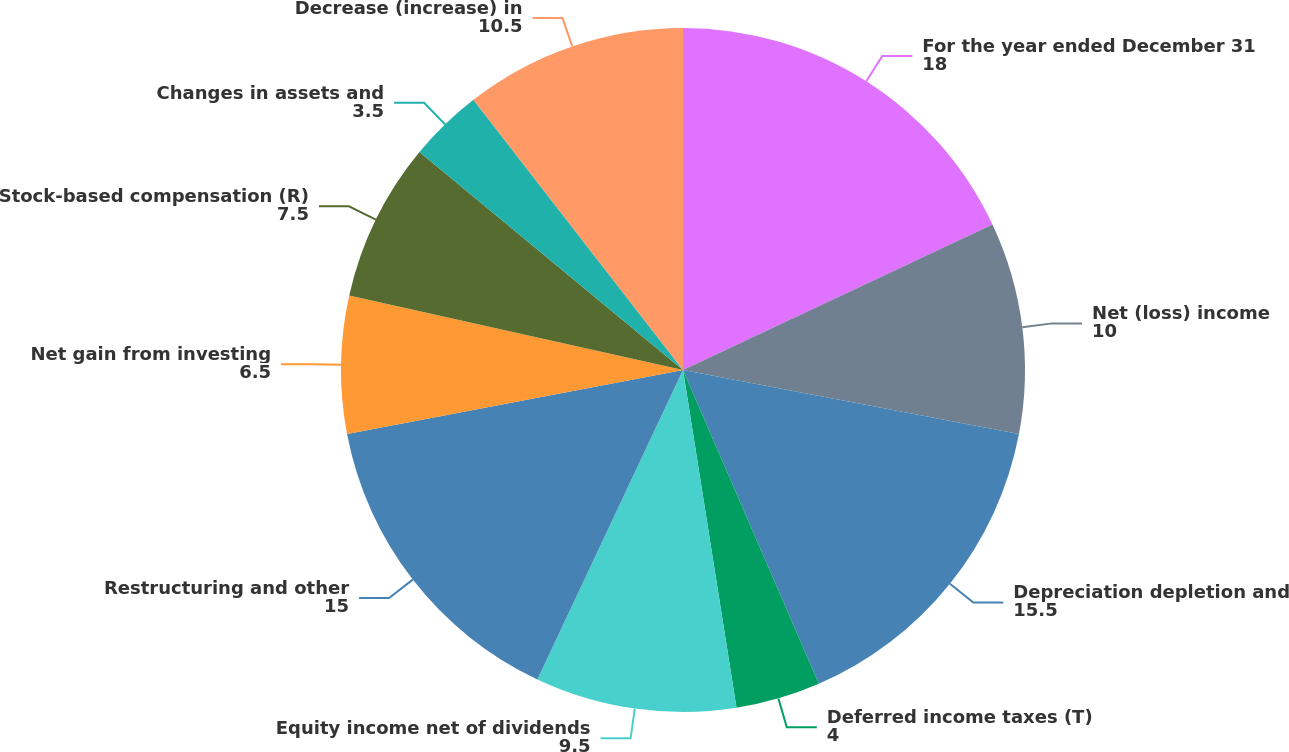Convert chart to OTSL. <chart><loc_0><loc_0><loc_500><loc_500><pie_chart><fcel>For the year ended December 31<fcel>Net (loss) income<fcel>Depreciation depletion and<fcel>Deferred income taxes (T)<fcel>Equity income net of dividends<fcel>Restructuring and other<fcel>Net gain from investing<fcel>Stock-based compensation (R)<fcel>Changes in assets and<fcel>Decrease (increase) in<nl><fcel>18.0%<fcel>10.0%<fcel>15.5%<fcel>4.0%<fcel>9.5%<fcel>15.0%<fcel>6.5%<fcel>7.5%<fcel>3.5%<fcel>10.5%<nl></chart> 